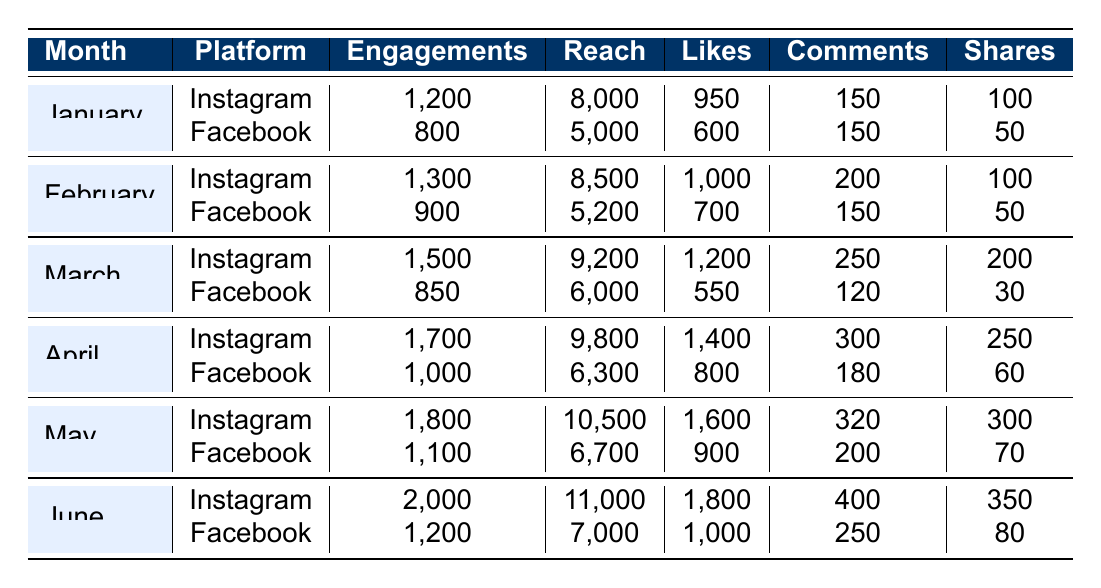What is the total number of engagements for Instagram in the month of April? In April, the number of engagements for Instagram is recorded as 1700.
Answer: 1700 Which platform had higher reach in February, Instagram or Facebook? In February, the reach for Instagram is 8500 and for Facebook is 5200. Since 8500 > 5200, Instagram had higher reach.
Answer: Instagram What are the total engagements on Facebook for the six months? The total engagements for Facebook are calculated by summing engagements from all months: (800 + 900 + 850 + 1000 + 1100 + 1200) = 4850.
Answer: 4850 Is the number of likes for Instagram consistently increasing each month? By comparing the likes for each month: January (950), February (1000), March (1200), April (1400), May (1600), June (1800), we see an increase every month.
Answer: Yes What was the average number of shares for Facebook over the six months? The shares for Facebook are: 50, 50, 30, 60, 70, 80. The total is 50 + 50 + 30 + 60 + 70 + 80 = 340. There are 6 months, so the average is 340 / 6 = 56.67.
Answer: 56.67 Which month saw the lowest engagements on Instagram? The engagement data for Instagram shows January had the lowest number with 1200 engagements, while all other months had higher values.
Answer: January What is the percentage increase in engagements for Instagram from March to June? The engagements for Instagram in March is 1500 and in June is 2000. The increase is 2000 - 1500 = 500. The percentage increase is (500 / 1500) * 100 = 33.33%.
Answer: 33.33% What is the total reach for Instagram over the entire period? The reach for Instagram month by month is: 8000 + 8500 + 9200 + 9800 + 10500 + 11000 = 57000.
Answer: 57000 In which month did Facebook have the highest number of comments? Checking the comments for Facebook: January (150), February (150), March (120), April (180), May (200), June (250). June had the most with 250 comments.
Answer: June 